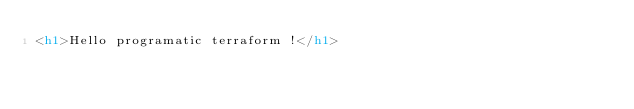Convert code to text. <code><loc_0><loc_0><loc_500><loc_500><_HTML_><h1>Hello programatic terraform !</h1>
</code> 